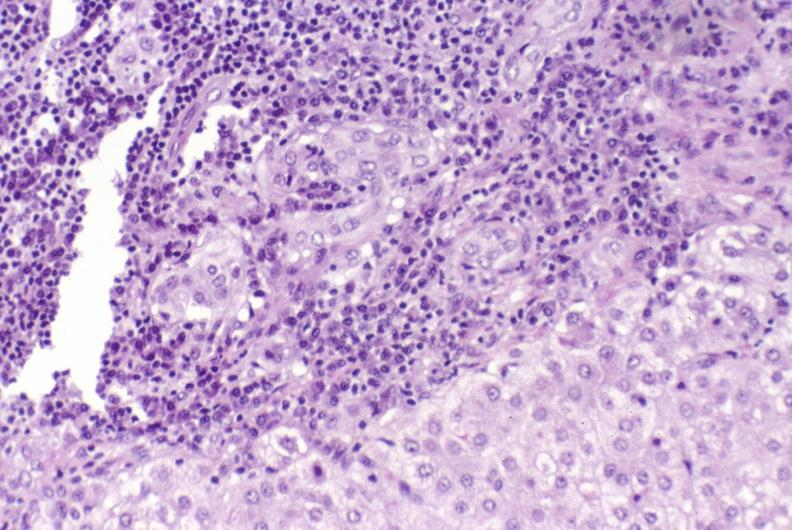what is present?
Answer the question using a single word or phrase. Hepatobiliary 